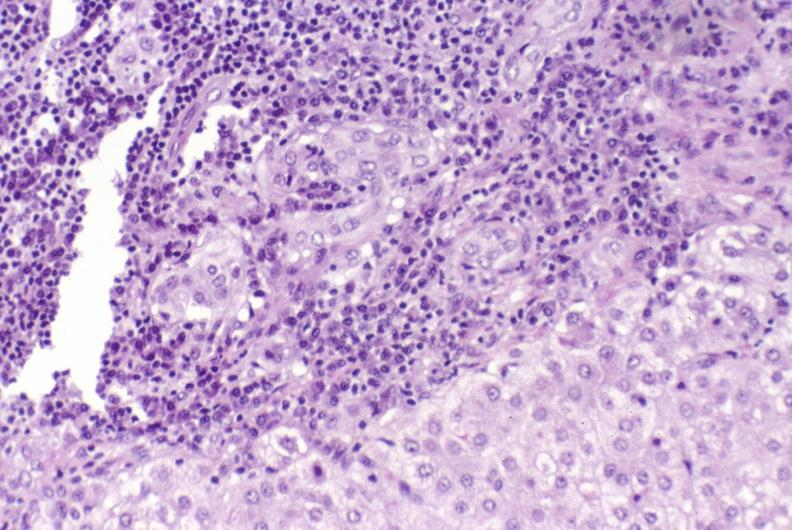what is present?
Answer the question using a single word or phrase. Hepatobiliary 